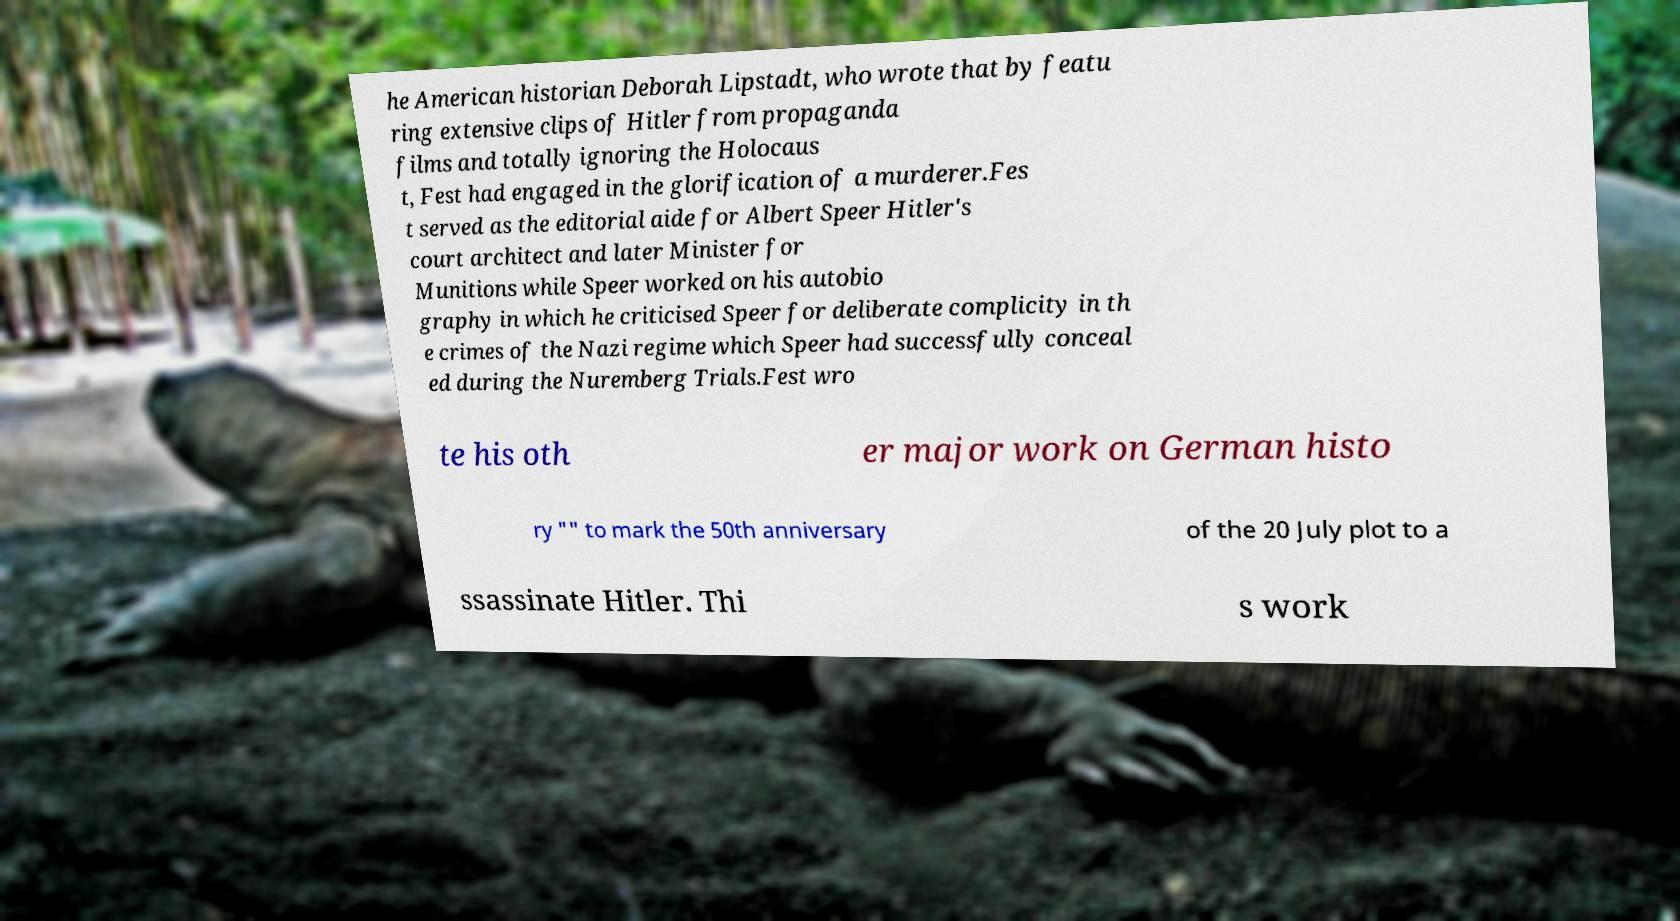There's text embedded in this image that I need extracted. Can you transcribe it verbatim? he American historian Deborah Lipstadt, who wrote that by featu ring extensive clips of Hitler from propaganda films and totally ignoring the Holocaus t, Fest had engaged in the glorification of a murderer.Fes t served as the editorial aide for Albert Speer Hitler's court architect and later Minister for Munitions while Speer worked on his autobio graphy in which he criticised Speer for deliberate complicity in th e crimes of the Nazi regime which Speer had successfully conceal ed during the Nuremberg Trials.Fest wro te his oth er major work on German histo ry "" to mark the 50th anniversary of the 20 July plot to a ssassinate Hitler. Thi s work 